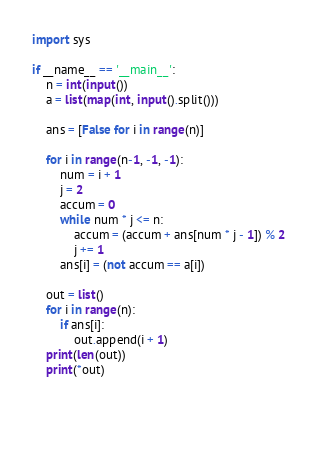<code> <loc_0><loc_0><loc_500><loc_500><_Python_>import sys

if __name__ == '__main__':
    n = int(input())
    a = list(map(int, input().split()))

    ans = [False for i in range(n)]

    for i in range(n-1, -1, -1):
        num = i + 1
        j = 2
        accum = 0
        while num * j <= n:
            accum = (accum + ans[num * j - 1]) % 2
            j += 1
        ans[i] = (not accum == a[i])

    out = list()
    for i in range(n):
        if ans[i]:
            out.append(i + 1)
    print(len(out))
    print(*out)


        </code> 